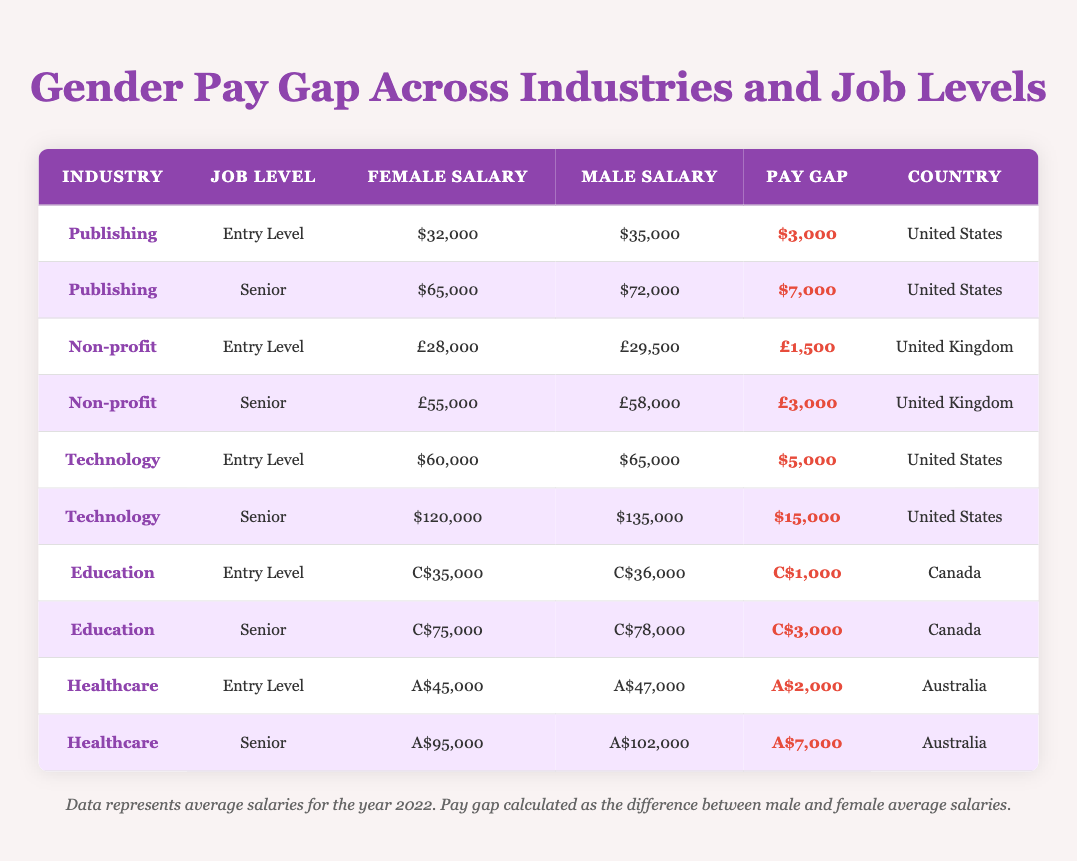What is the average pay gap for the Publishing industry at the Senior level? The Senior level salaries for females in Publishing are $65,000 and for males are $72,000. The pay gap is calculated as the difference: $72,000 - $65,000 = $7,000.
Answer: $7,000 What is the average salary for female employees in the Technology industry at the Senior level? The Technology industry at the Senior level has an average salary for females of $120,000. This value can be found by directly looking at the corresponding row in the table.
Answer: $120,000 Is the pay gap higher in the Healthcare industry or the Non-profit industry for Entry Level positions? For Healthcare Entry Level, the pay gap is $2,000 (A$47,000 - A$45,000) and for Non-profit Entry Level, it is £1,500 (£29,500 - £28,000). Comparing these two, $2,000 is greater than £1,500. Therefore, the pay gap is higher in Healthcare.
Answer: Yes In which industry and job level is the smallest pay gap observed? By reviewing the table, the smallest pay gap is found in Education for Entry Level, where the female salary is C$35,000, and the male salary is C$36,000. The pay gap is C$1,000.
Answer: Education, Entry Level What are the average salaries for both genders in the Healthcare industry at the Senior level? The average salary for females in Healthcare (Senior) is $95,000, and for males, it is $102,000. These values can be found directly in the Healthcare Senior row of the table.
Answer: Females: $95,000, Males: $102,000 Which job level in the Technology industry has the highest pay gap? Comparing the pay gaps in Technology: Entry Level has a $5,000 gap ($65,000 - $60,000), while Senior has a $15,000 gap ($135,000 - $120,000). The Senior level has the highest pay gap of $15,000.
Answer: Senior Level Do females earn less than males at every job level across the provided industries? By analyzing the table, there are pay gaps favoring males at every indicated job level and industry. This suggests that females earn less than males across the board.
Answer: Yes Calculate the total average salary difference between female and male employees across all industries at the Senior level. Summing up the Senior level pay gaps, they are: Publishing ($7,000) + Non-profit ($3,000) + Technology ($15,000) + Education ($3,000) + Healthcare ($7,000) = $35,000. This represents the total difference across all Senior levels.
Answer: $35,000 